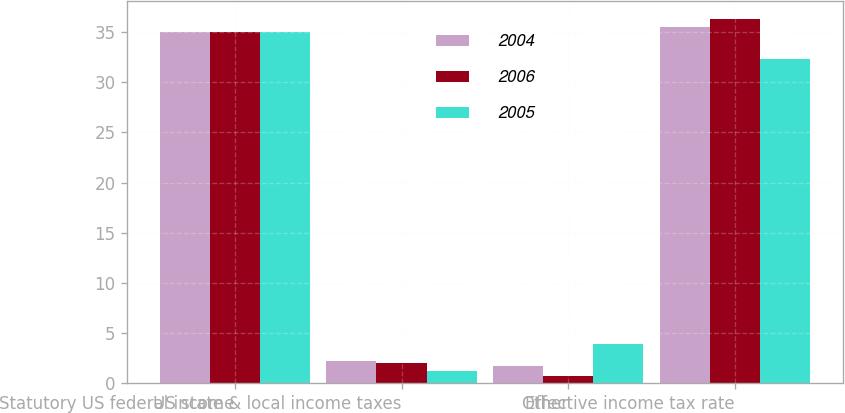Convert chart. <chart><loc_0><loc_0><loc_500><loc_500><stacked_bar_chart><ecel><fcel>Statutory US federal income<fcel>US state & local income taxes<fcel>Other<fcel>Effective income tax rate<nl><fcel>2004<fcel>35<fcel>2.2<fcel>1.7<fcel>35.5<nl><fcel>2006<fcel>35<fcel>2<fcel>0.7<fcel>36.3<nl><fcel>2005<fcel>35<fcel>1.2<fcel>3.9<fcel>32.3<nl></chart> 